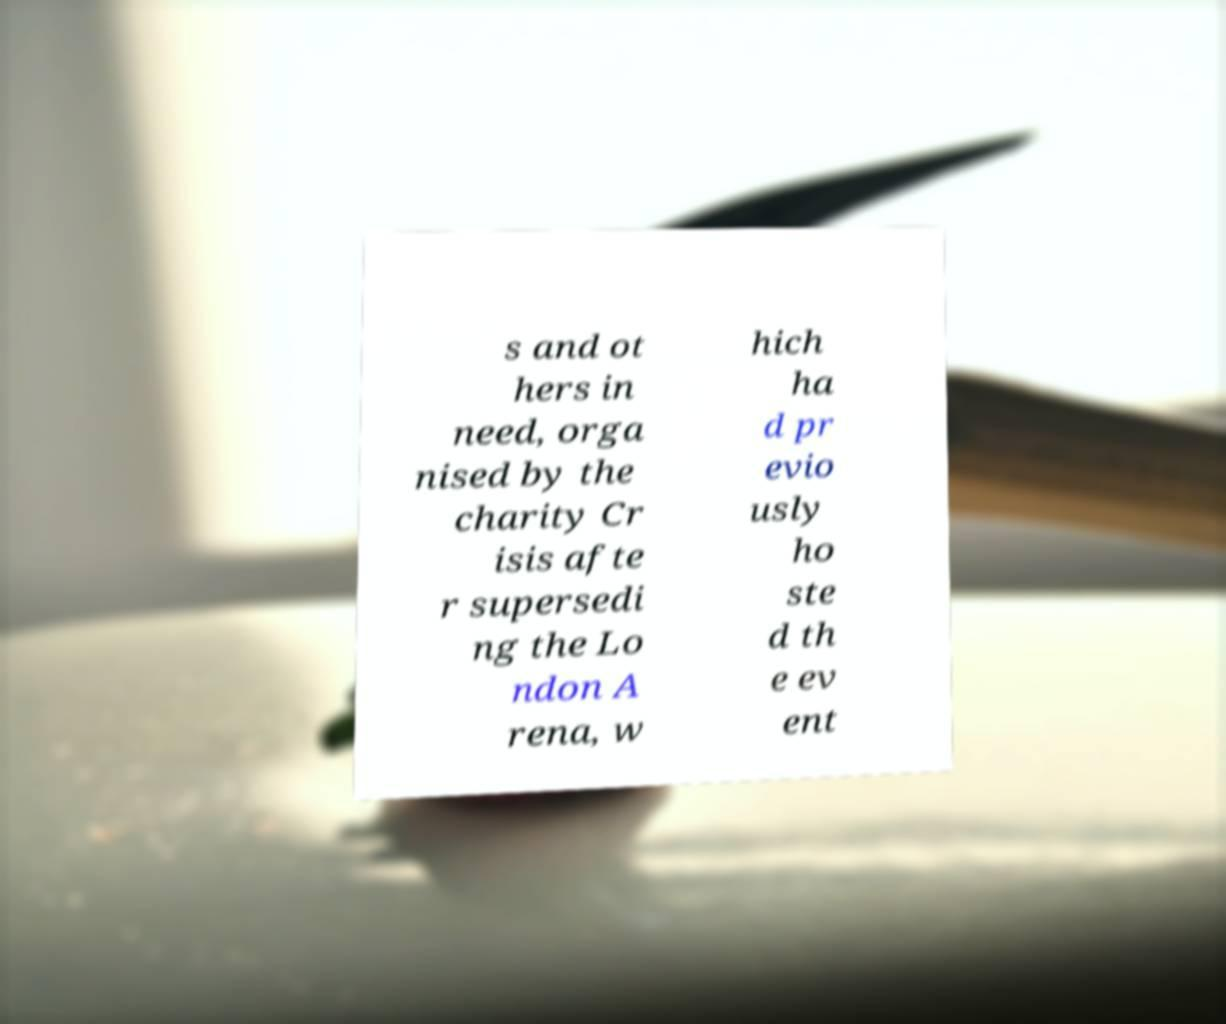Could you extract and type out the text from this image? s and ot hers in need, orga nised by the charity Cr isis afte r supersedi ng the Lo ndon A rena, w hich ha d pr evio usly ho ste d th e ev ent 